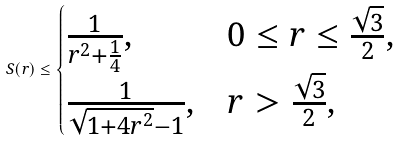<formula> <loc_0><loc_0><loc_500><loc_500>S ( r ) \leq \begin{cases} \frac { 1 } { r ^ { 2 } + \frac { 1 } { 4 } } , & 0 \leq r \leq \frac { \sqrt { 3 } } { 2 } , \\ \frac { 1 } { \sqrt { 1 + 4 r ^ { 2 } } - 1 } , & r > \frac { \sqrt { 3 } } { 2 } , \end{cases}</formula> 